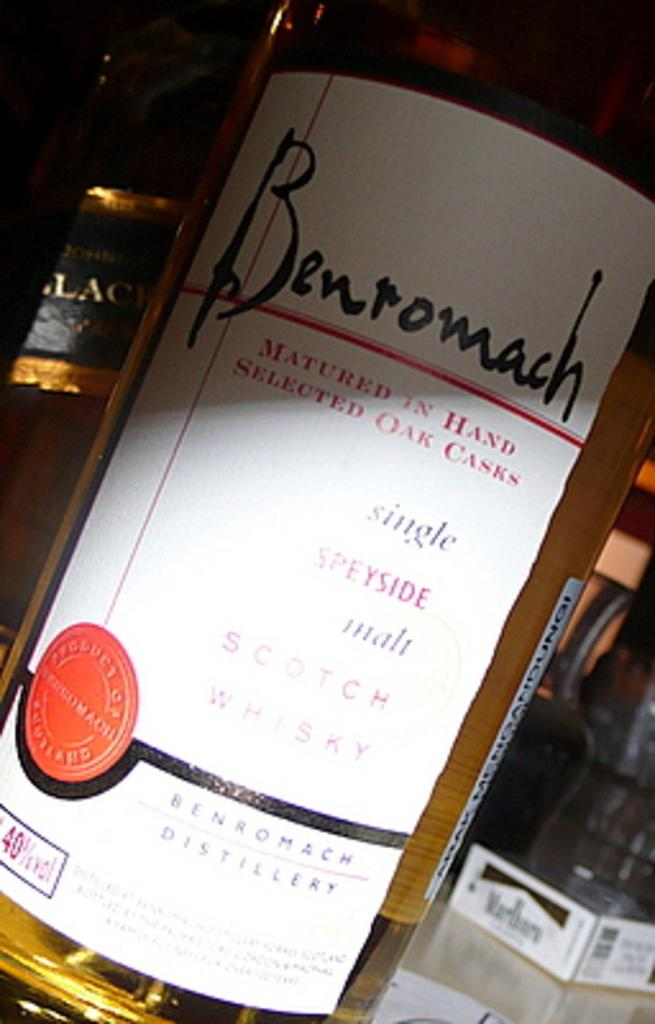<image>
Offer a succinct explanation of the picture presented. bottle of benromach wine matured in hand selected oak casks 